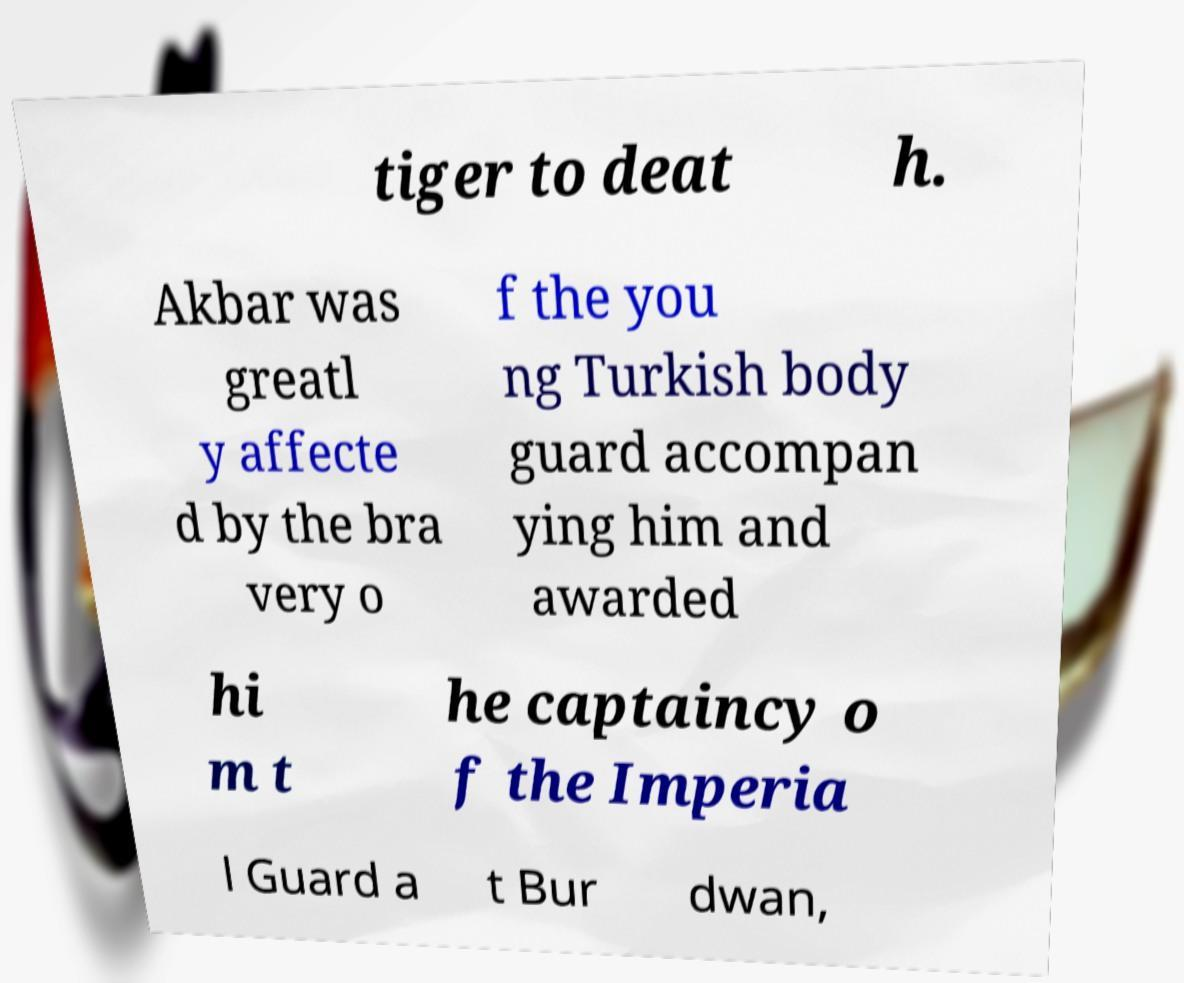I need the written content from this picture converted into text. Can you do that? tiger to deat h. Akbar was greatl y affecte d by the bra very o f the you ng Turkish body guard accompan ying him and awarded hi m t he captaincy o f the Imperia l Guard a t Bur dwan, 